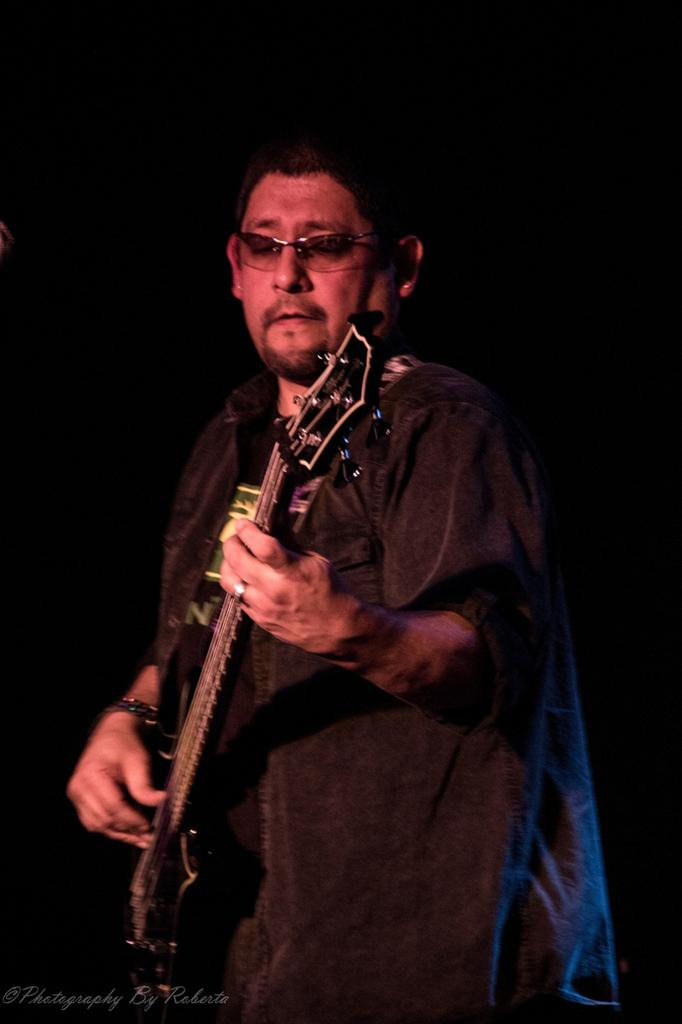What is the main subject of the image? There is a person in the image. What is the person doing in the image? The person is standing and playing a guitar. What type of eggnog is the person drinking in the image? There is no eggnog present in the image; the person is playing a guitar. What organization is the person representing in the image? There is no indication of any organization in the image; it simply shows a person playing a guitar. 